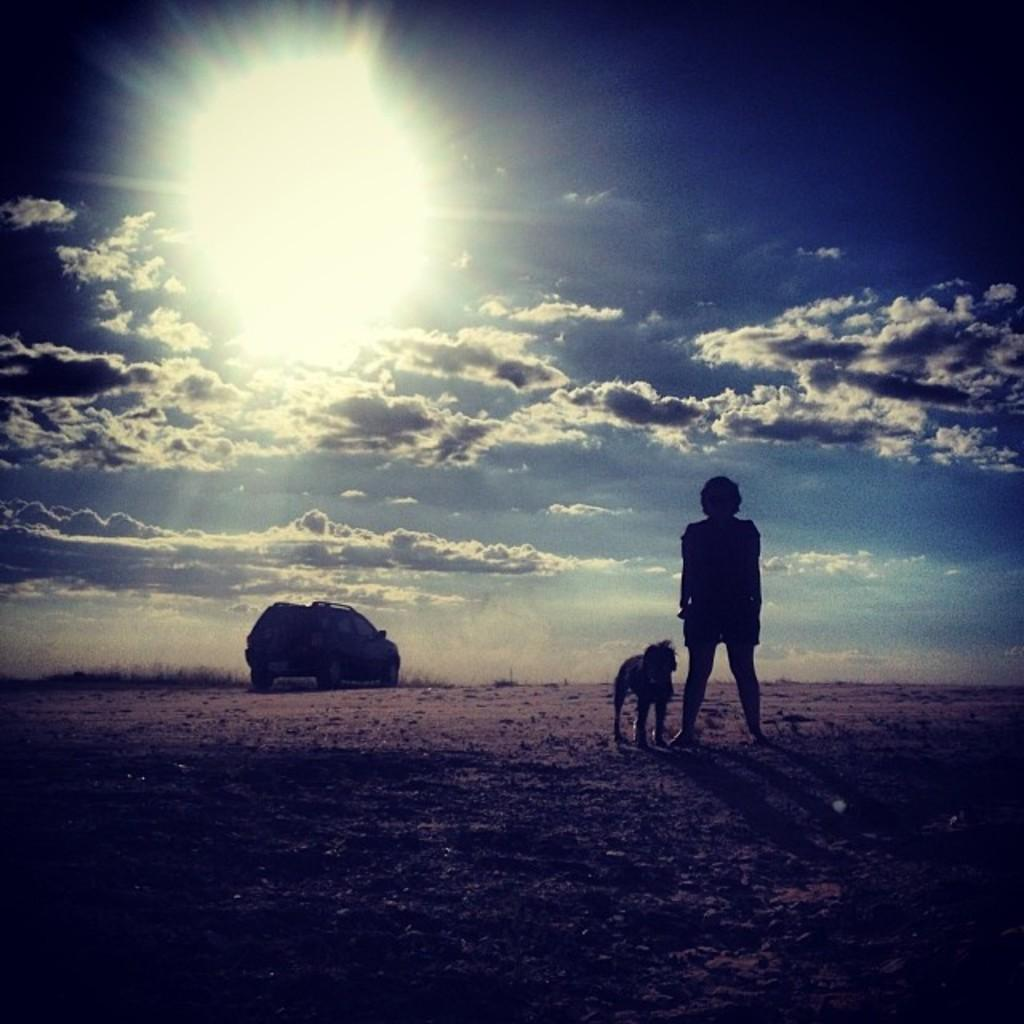What is the main subject in the image? There is a person standing in the image. What other living creature is present in the image? There is an animal in the image. What type of man-made object can be seen in the image? There is a vehicle in the image. What type of natural environment is visible in the image? There is grass in the image. What is visible in the background of the image? The sky is visible in the background of the image. What type of calendar is hanging on the wall in the image? There is no calendar present in the image. Can you tell me how many volleyballs are visible in the image? There are no volleyballs visible in the image. 